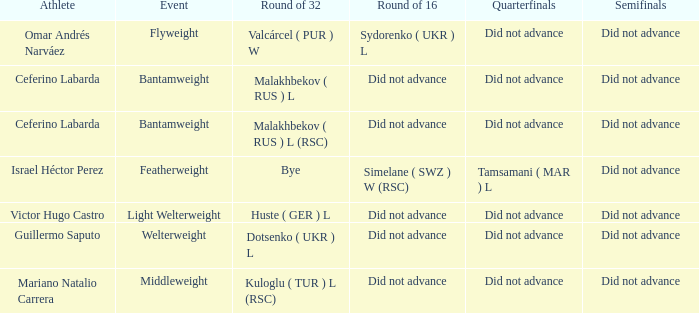When there was a bye in the round of 32, what was the result in the round of 16? Did not advance. 